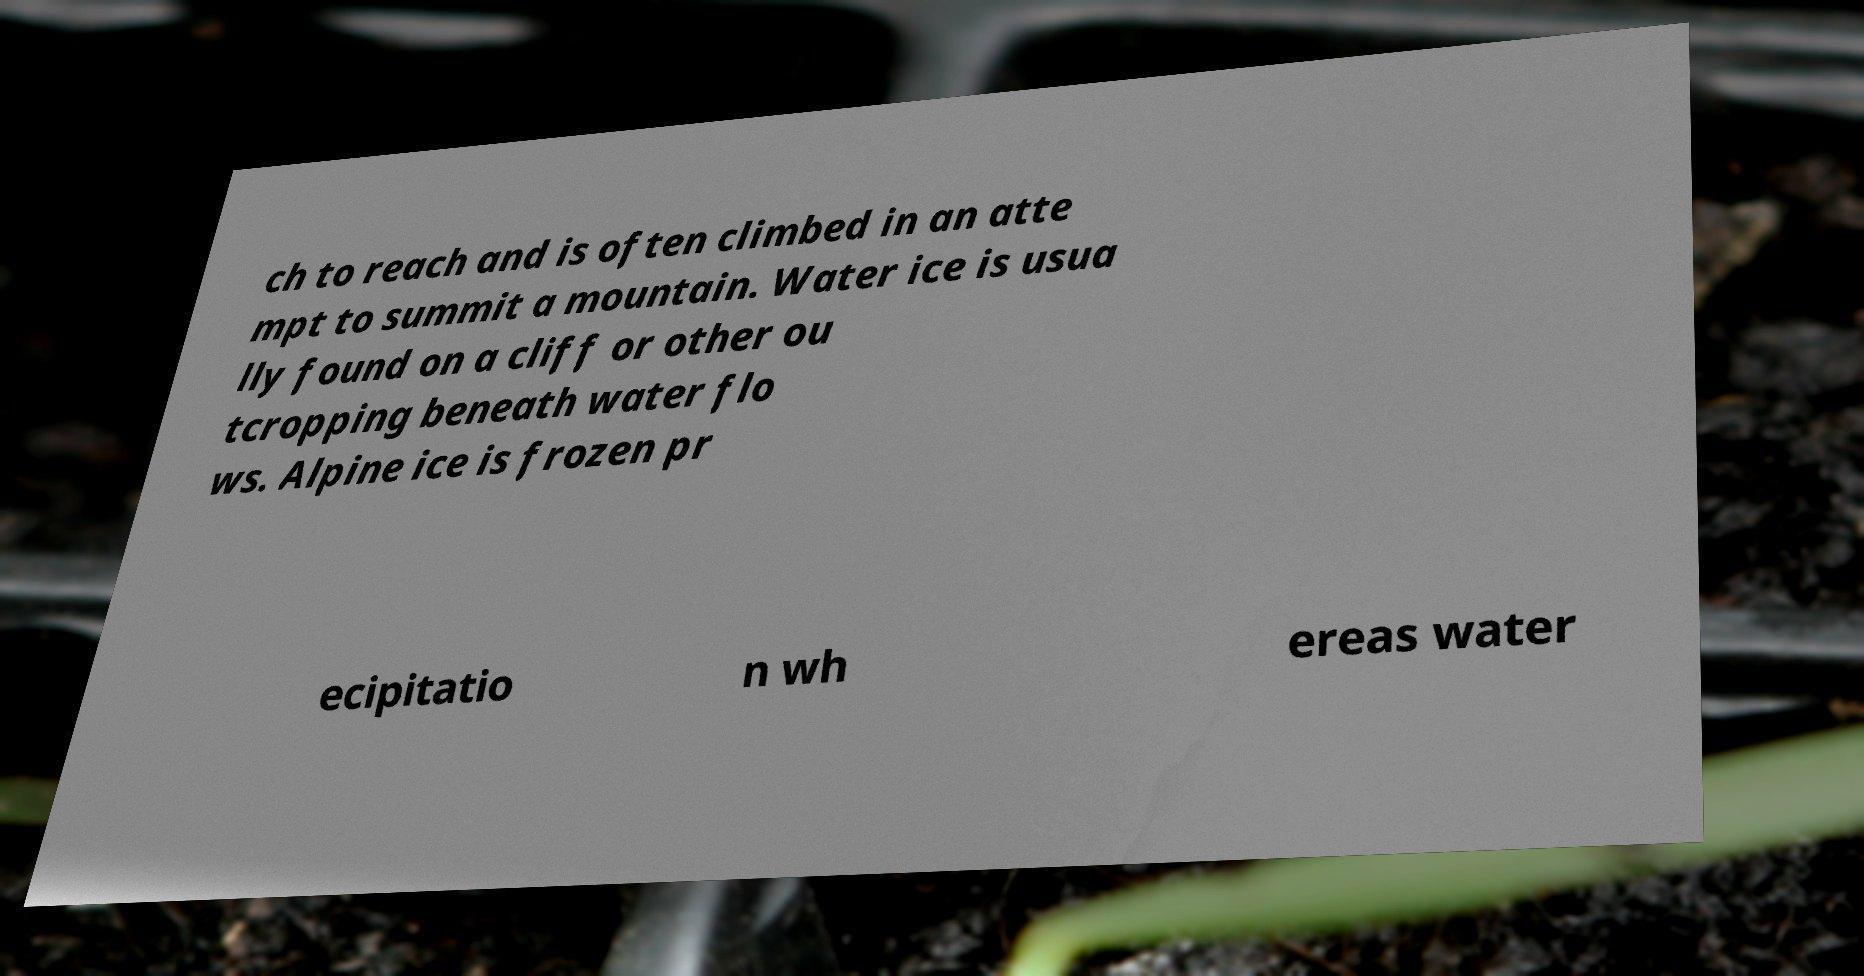Can you read and provide the text displayed in the image?This photo seems to have some interesting text. Can you extract and type it out for me? ch to reach and is often climbed in an atte mpt to summit a mountain. Water ice is usua lly found on a cliff or other ou tcropping beneath water flo ws. Alpine ice is frozen pr ecipitatio n wh ereas water 